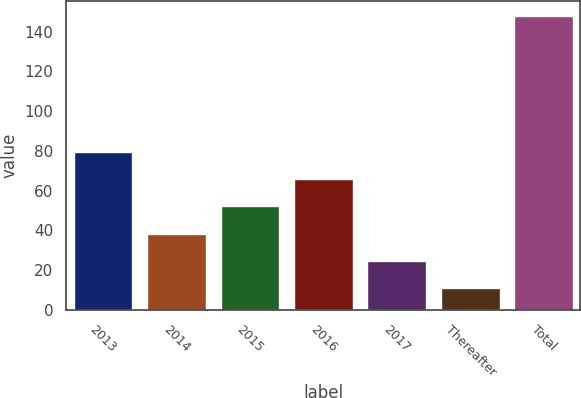<chart> <loc_0><loc_0><loc_500><loc_500><bar_chart><fcel>2013<fcel>2014<fcel>2015<fcel>2016<fcel>2017<fcel>Thereafter<fcel>Total<nl><fcel>79.5<fcel>38.4<fcel>52.1<fcel>65.8<fcel>24.7<fcel>11<fcel>148<nl></chart> 